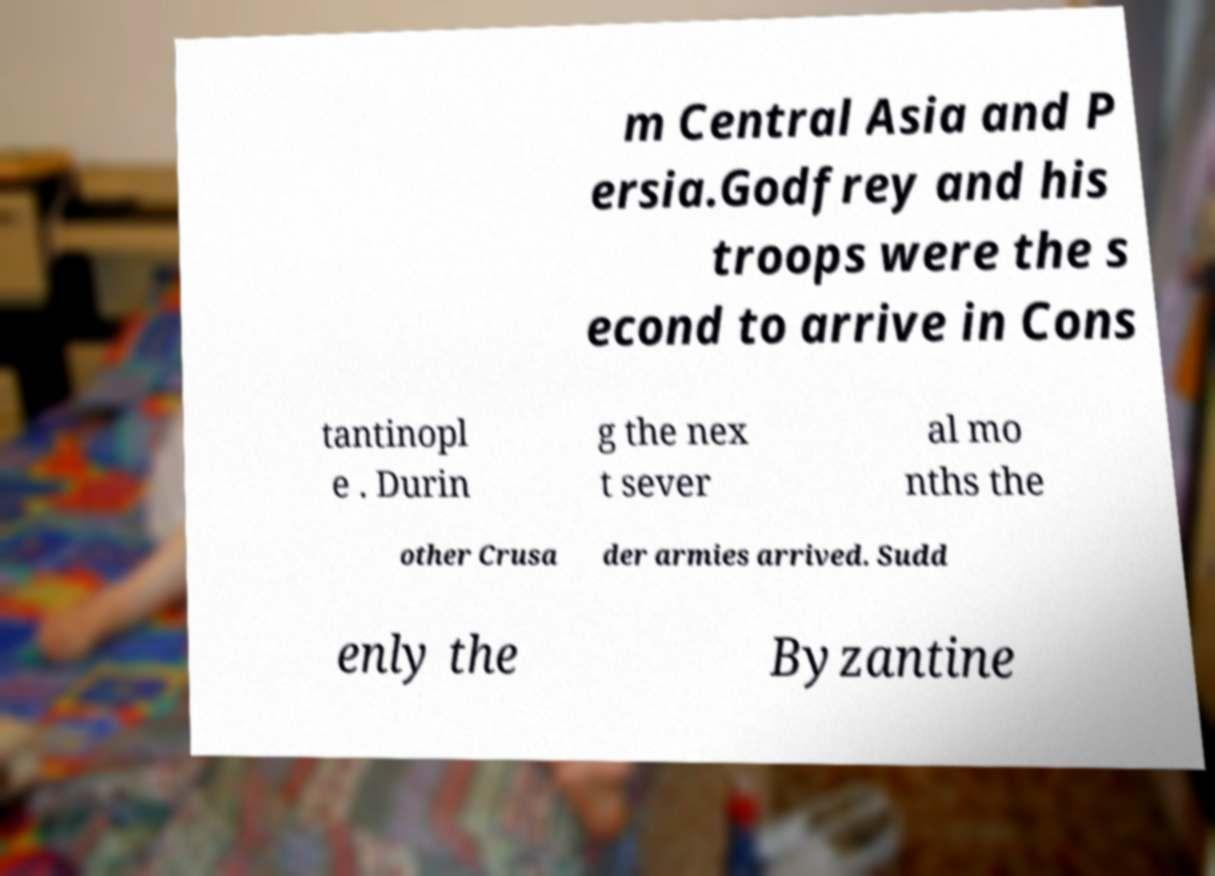I need the written content from this picture converted into text. Can you do that? m Central Asia and P ersia.Godfrey and his troops were the s econd to arrive in Cons tantinopl e . Durin g the nex t sever al mo nths the other Crusa der armies arrived. Sudd enly the Byzantine 